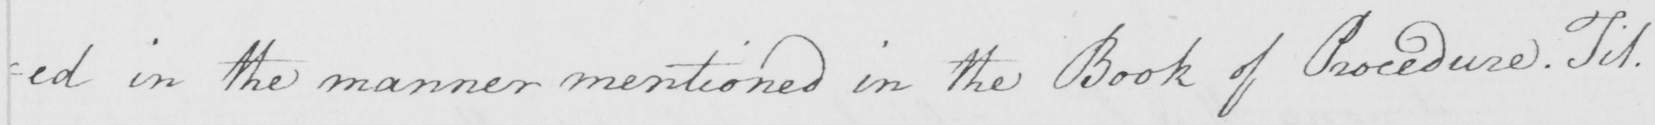Please provide the text content of this handwritten line. =ed in the manner mentioned in the Book of Procedure. Tit. 